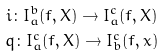Convert formula to latex. <formula><loc_0><loc_0><loc_500><loc_500>i \colon I _ { a } ^ { b } ( f , X ) \to I _ { a } ^ { c } ( f , X ) \\ q \colon I _ { a } ^ { c } ( f , X ) \to I _ { b } ^ { c } ( f , x )</formula> 